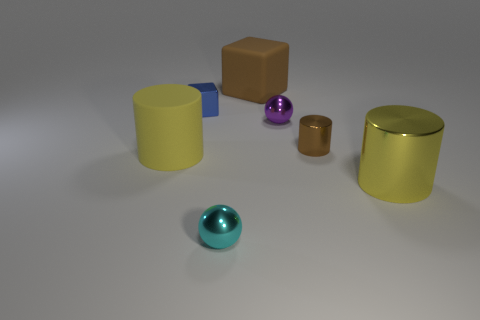What is the material of the blue cube that is the same size as the cyan metallic sphere?
Keep it short and to the point. Metal. Do the cylinder that is on the left side of the small purple metal sphere and the brown thing in front of the tiny blue thing have the same size?
Make the answer very short. No. What number of things are tiny shiny objects or tiny metallic spheres that are behind the cyan metallic sphere?
Offer a very short reply. 4. Is there another large metallic thing of the same shape as the large brown thing?
Give a very brief answer. No. How big is the yellow object to the left of the large cylinder that is in front of the matte cylinder?
Give a very brief answer. Large. Is the color of the large rubber block the same as the tiny metallic cylinder?
Your answer should be compact. Yes. How many matte things are either yellow cylinders or large green cylinders?
Provide a succinct answer. 1. How many big red matte balls are there?
Your answer should be compact. 0. Does the cyan thing on the left side of the small brown metallic object have the same material as the large yellow thing that is to the left of the small brown metal cylinder?
Give a very brief answer. No. What is the color of the big thing that is the same shape as the tiny blue object?
Keep it short and to the point. Brown. 